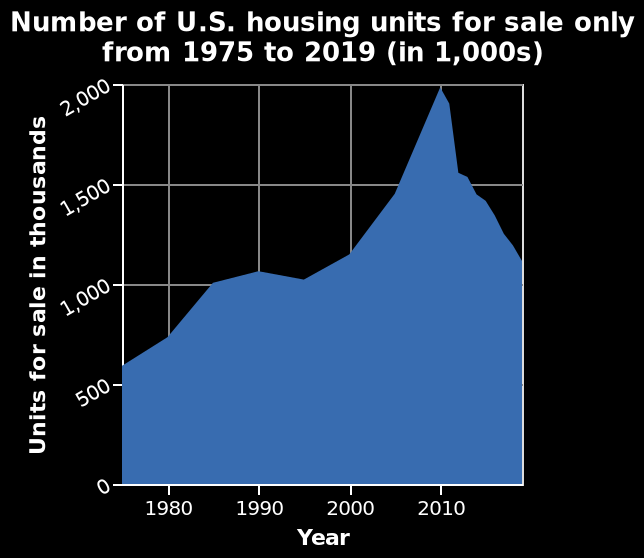<image>
What is the time range of the data represented in the graph? The time range of the data represented in the graph is from 1975 to 2019. 